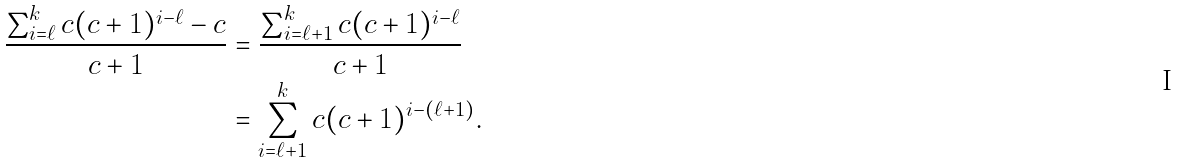<formula> <loc_0><loc_0><loc_500><loc_500>\frac { \sum _ { i = \ell } ^ { k } c ( c + 1 ) ^ { i - \ell } - c } { c + 1 } & = \frac { \sum _ { i = \ell + 1 } ^ { k } c ( c + 1 ) ^ { i - \ell } } { c + 1 } \\ & = \sum _ { i = \ell + 1 } ^ { k } c ( c + 1 ) ^ { i - ( \ell + 1 ) } .</formula> 